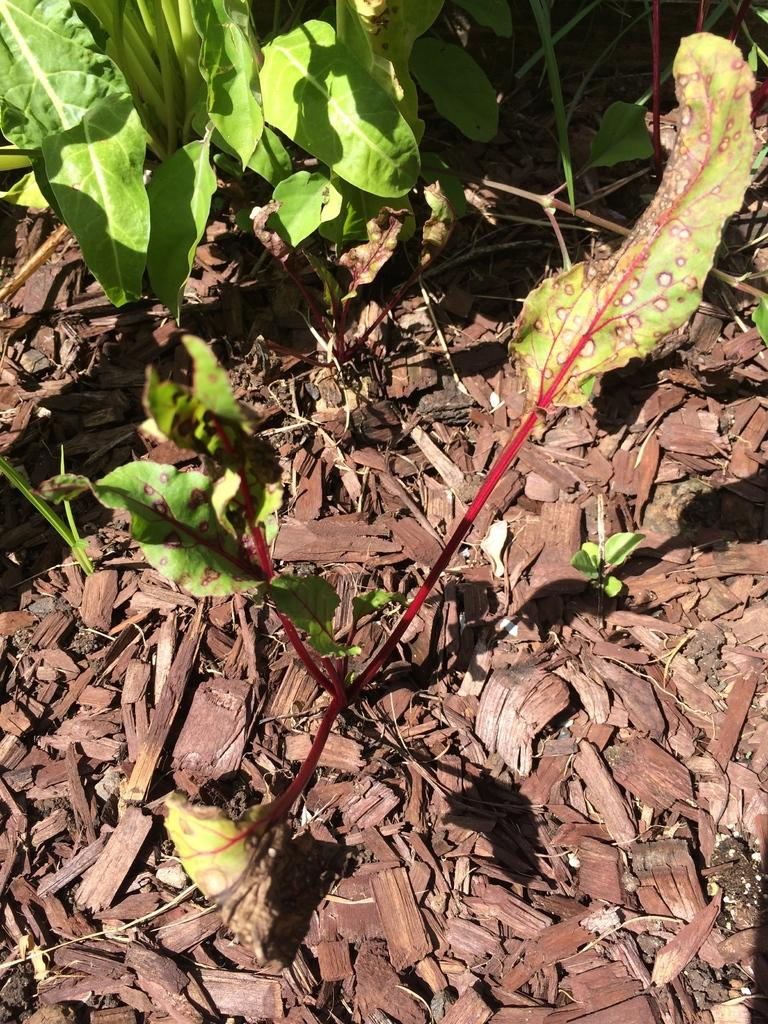What type of plants are visible in the image? There are plants with green leaves in the image. Can you describe the land in the image? There is a land with some leaves at the bottom of the image. How many cherries are hanging from the plants in the image? There are no cherries visible in the image; only plants with green leaves are present. What offer is being made by the plants in the image? The plants in the image are not making any offers; they are simply growing with green leaves. 